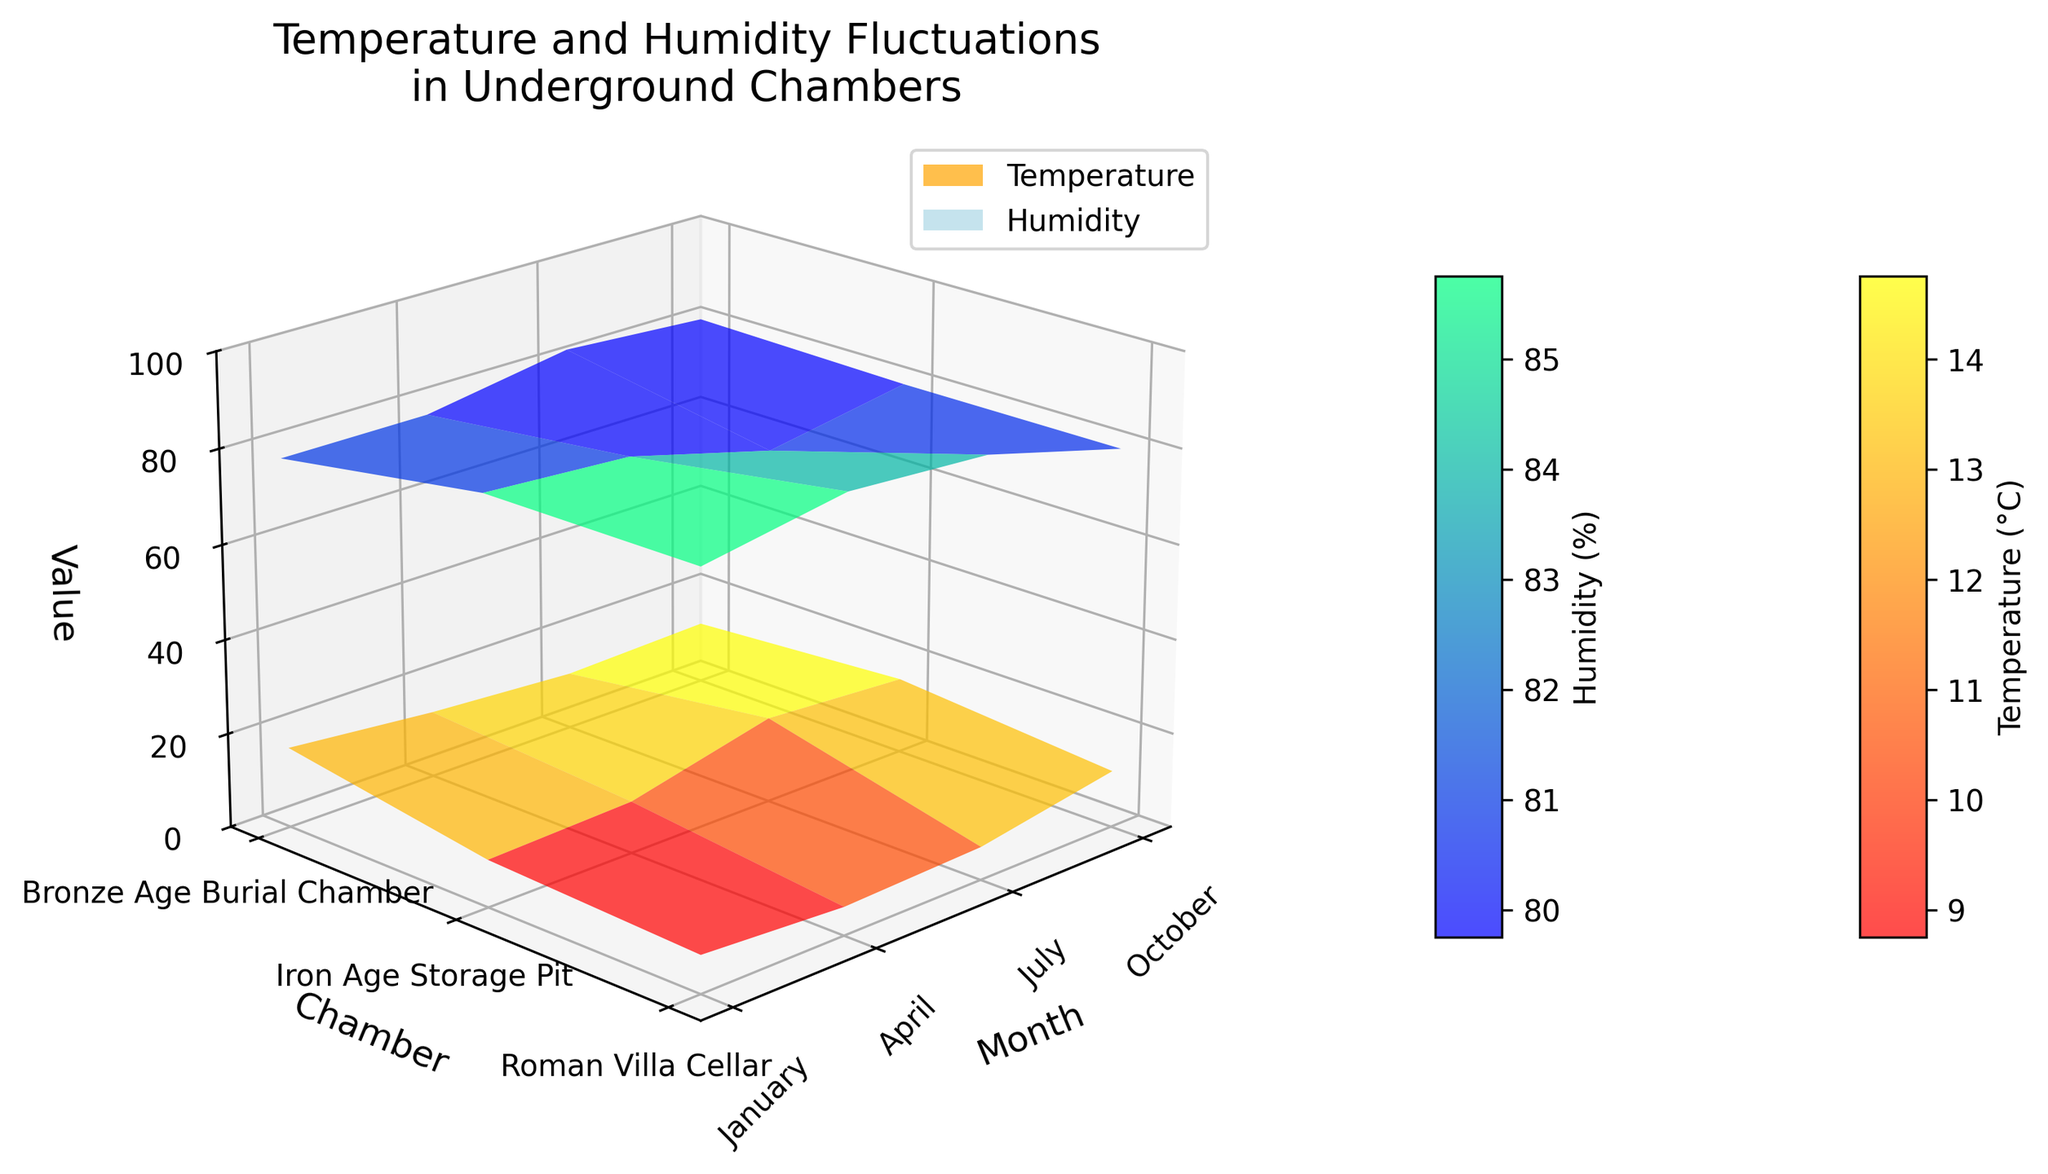What is the title of the figure? The title of the figure can be found at the top of the plot. In this case, it reads "Temperature and Humidity Fluctuations in Underground Chambers".
Answer: Temperature and Humidity Fluctuations in Underground Chambers Which chamber exhibits the highest temperature in July? The Roman Villa Cellar is at the highest point of the temperature surface in July, reaching 18°C, which is visible by looking at the peak of the 'autumn' colored surface in the July column.
Answer: Roman Villa Cellar In which month is the humidity lowest in the Bronze Age Burial Chamber? The lowest point on the blue (winter) surface for the Bronze Age Burial Chamber, which corresponds to the lowest value, is in July, where humidity is 78%.
Answer: July What is the difference in temperature between the Roman Villa Cellar in January and July? The temperature in the Roman Villa Cellar in January is 8°C, and in July it is 18°C. The difference is calculated as 18 - 8 = 10°C.
Answer: 10°C Which chamber has the least humidity in January? In January, the blue surface shows the lowest humidity in the Roman Villa Cellar, which is 85%. The Iron Age Storage Pit and Bronze Age Burial Chamber have higher humidity values of 90% and 88%, respectively.
Answer: Roman Villa Cellar By how much does the humidity in the Iron Age Storage Pit decrease from January to April? The humidity in the Iron Age Storage Pit is 90% in January and 85% in April. The decrease is calculated as 90 - 85 = 5%.
Answer: 5% What is the overall trend of temperature changes across the months? Observing the 'autumn' surface reveals an increasing trend in temperature from January through July, followed by a slight decrease in October across all chambers. This indicates temperatures rise towards mid-year and then decline.
Answer: Increase then slight decrease Which chamber shows the smallest seasonal fluctuation in temperature? The Iron Age Storage Pit shows the smallest range of temperature fluctuations, from 6°C in January to 16°C in July, a total range of 10°C. Other chambers have larger ranges: the Roman Villa Cellar fluctuates by 10°C and the Bronze Age Burial Chamber by 10°C.
Answer: Iron Age Storage Pit 